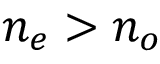<formula> <loc_0><loc_0><loc_500><loc_500>n _ { e } > n _ { o }</formula> 